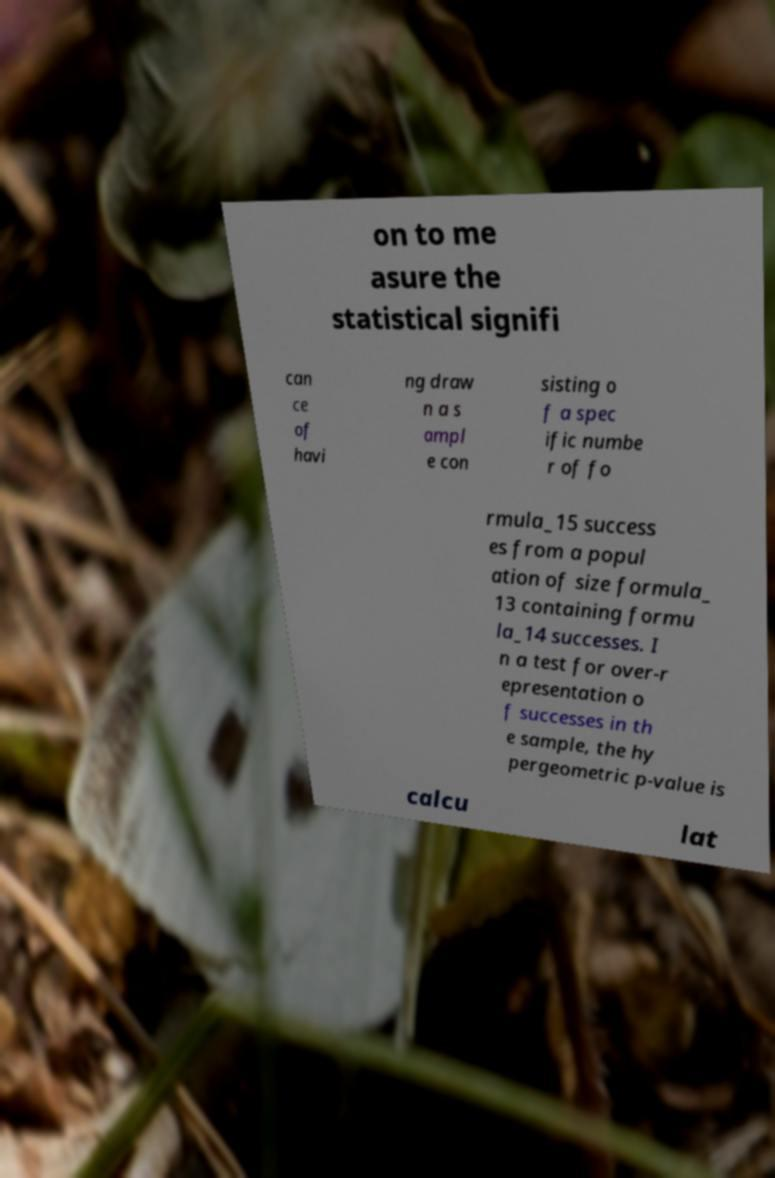There's text embedded in this image that I need extracted. Can you transcribe it verbatim? on to me asure the statistical signifi can ce of havi ng draw n a s ampl e con sisting o f a spec ific numbe r of fo rmula_15 success es from a popul ation of size formula_ 13 containing formu la_14 successes. I n a test for over-r epresentation o f successes in th e sample, the hy pergeometric p-value is calcu lat 